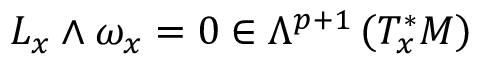<formula> <loc_0><loc_0><loc_500><loc_500>L _ { x } \wedge \omega _ { x } = 0 \in \Lambda ^ { p + 1 } \left ( T _ { x } ^ { * } M \right )</formula> 